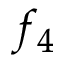Convert formula to latex. <formula><loc_0><loc_0><loc_500><loc_500>f _ { 4 }</formula> 